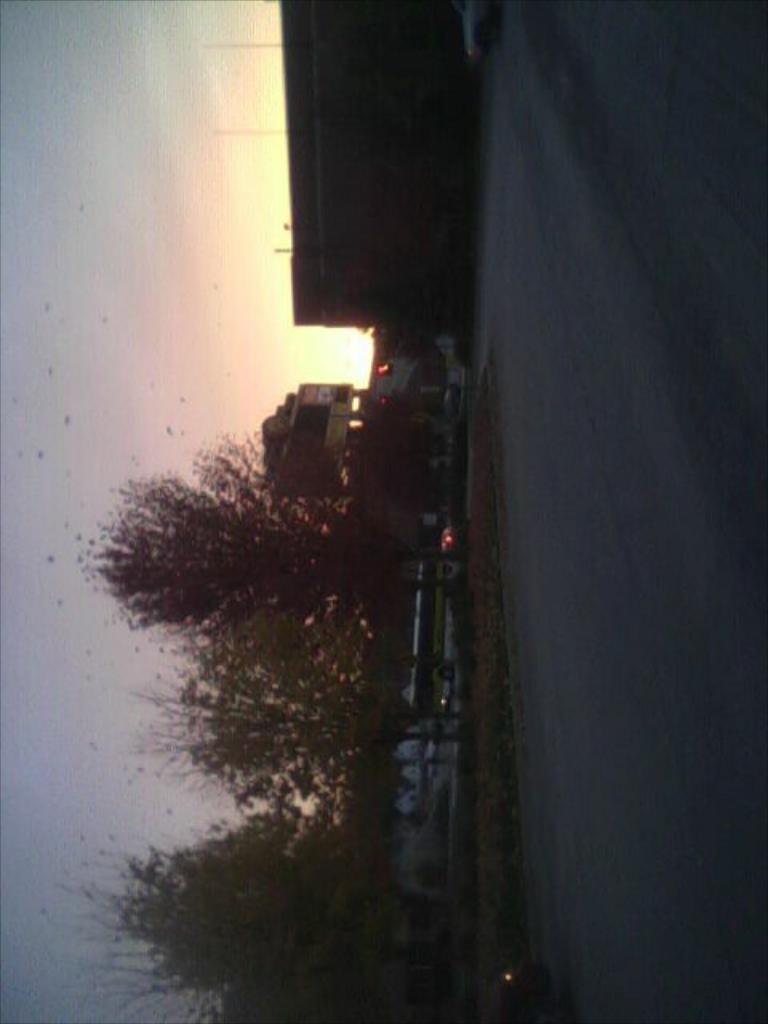How would you summarize this image in a sentence or two? In this picture I can see few trees and vehicles in the middle, at the top there are buildings. In the background I can see the sky, on the left side there is a road. 